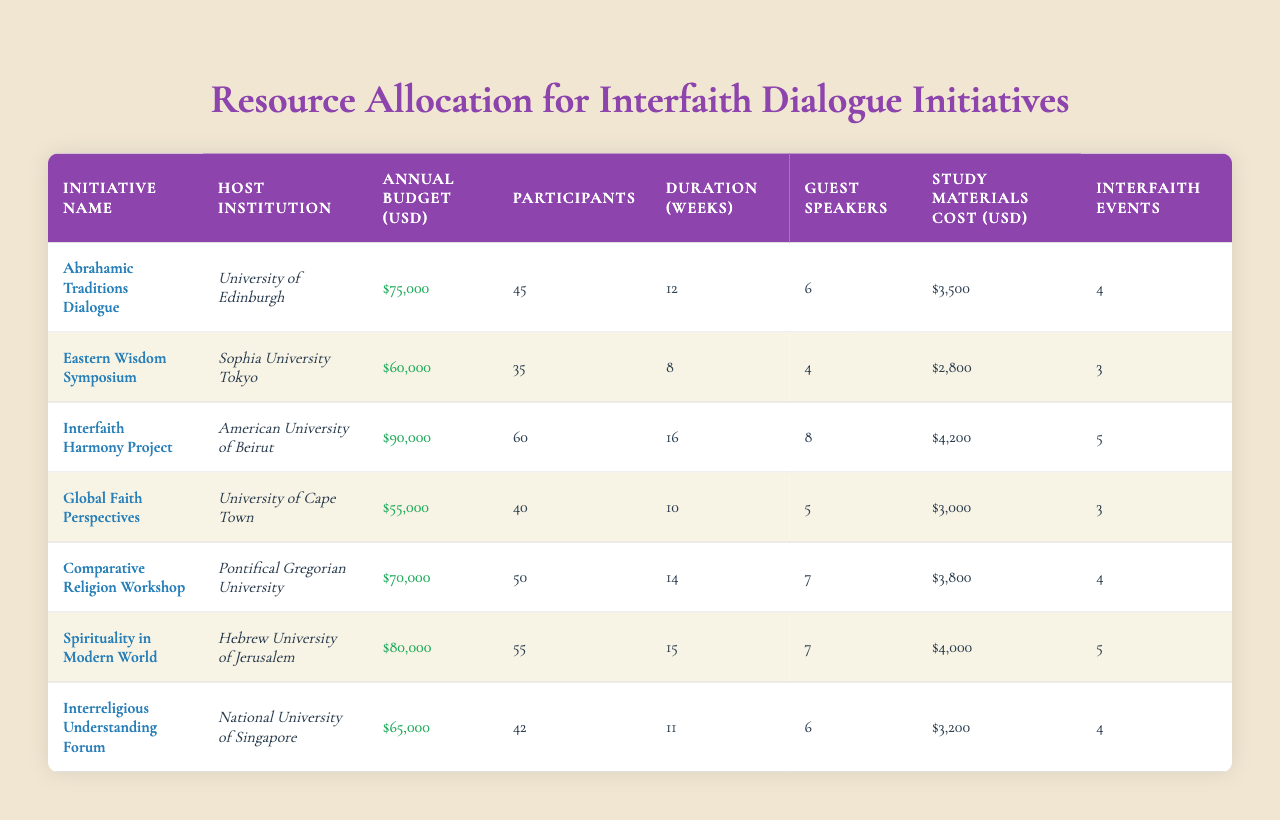What is the highest annual budget for an initiative listed? The highest annual budget can be found by examining the "Annual Budget (USD)" column. The maximum value in this column is $90,000 for the "Interfaith Harmony Project" at the American University of Beirut.
Answer: $90,000 How many participants are involved in the "Spirituality in Modern World" initiative? Looking at the row for "Spirituality in Modern World," the number of participants listed is 55.
Answer: 55 Which initiative has the lowest study materials cost? The "Study Materials Cost (USD)" column shows costs for different initiatives. The minimum value in this column is $2,800 for the "Eastern Wisdom Symposium."
Answer: $2,800 How many interfaith events were organized by the "Abrahamic Traditions Dialogue"? By checking the row for the "Abrahamic Traditions Dialogue," we see that the number of interfaith events organized is 4.
Answer: 4 What is the average annual budget for the initiatives listed? First, we need to sum all the annual budgets: $75,000 + $60,000 + $90,000 + $55,000 + $70,000 + $80,000 + $65,000 = $495,000. There are 7 initiatives, so the average budget is $495,000 / 7 = $70,714.29.
Answer: $70,714.29 Is the "Comparative Religion Workshop" duration longer than the "Global Faith Perspectives"? The duration for the "Comparative Religion Workshop" is 14 weeks, while the "Global Faith Perspectives" duration is 10 weeks. Since 14 is greater than 10, the statement is true.
Answer: Yes Which host institution has organized the most number of guest speakers? To determine this, we look at the "Guest Speakers" column. The "Interfaith Harmony Project" has 8 guest speakers, which is the highest count compared to others.
Answer: American University of Beirut What is the total number of participants across all initiatives? We add the number of participants from each initiative: 45 + 35 + 60 + 40 + 50 + 55 + 42 = 327.
Answer: 327 Which initiative has a longer duration, "Eastern Wisdom Symposium" or "Global Faith Perspectives"? The "Eastern Wisdom Symposium" lasts for 8 weeks, and "Global Faith Perspectives" lasts for 10 weeks. Since 10 is greater than 8, "Global Faith Perspectives" has a longer duration.
Answer: Global Faith Perspectives How much did the "Interreligious Understanding Forum" spend on study materials relative to its budget? The budget for the "Interreligious Understanding Forum" is $65,000 and the study materials cost is $3,200. To find the proportion, we divide $3,200 by $65,000 = 0.0492, or about 4.92%.
Answer: 4.92% 